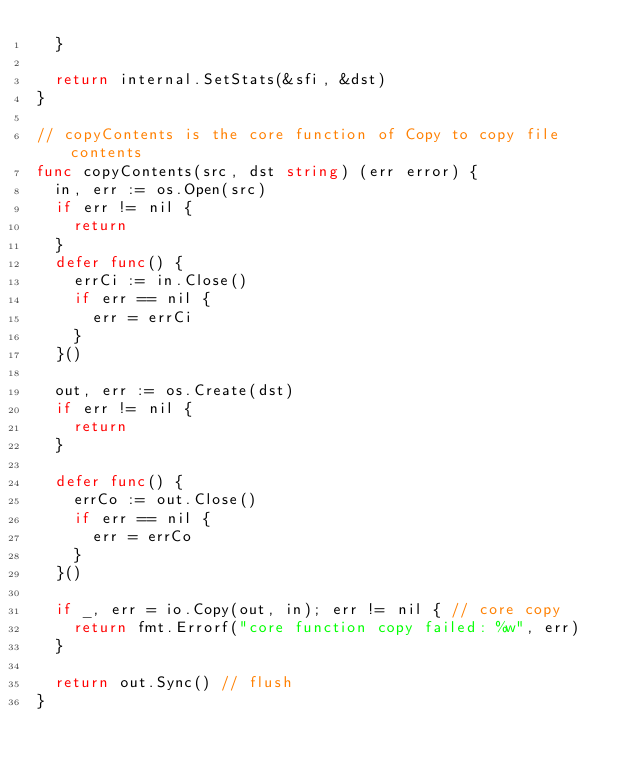<code> <loc_0><loc_0><loc_500><loc_500><_Go_>	}

	return internal.SetStats(&sfi, &dst)
}

// copyContents is the core function of Copy to copy file contents
func copyContents(src, dst string) (err error) {
	in, err := os.Open(src)
	if err != nil {
		return
	}
	defer func() {
		errCi := in.Close()
		if err == nil {
			err = errCi
		}
	}()

	out, err := os.Create(dst)
	if err != nil {
		return
	}

	defer func() {
		errCo := out.Close()
		if err == nil {
			err = errCo
		}
	}()

	if _, err = io.Copy(out, in); err != nil { // core copy
		return fmt.Errorf("core function copy failed: %w", err)
	}

	return out.Sync() // flush
}
</code> 